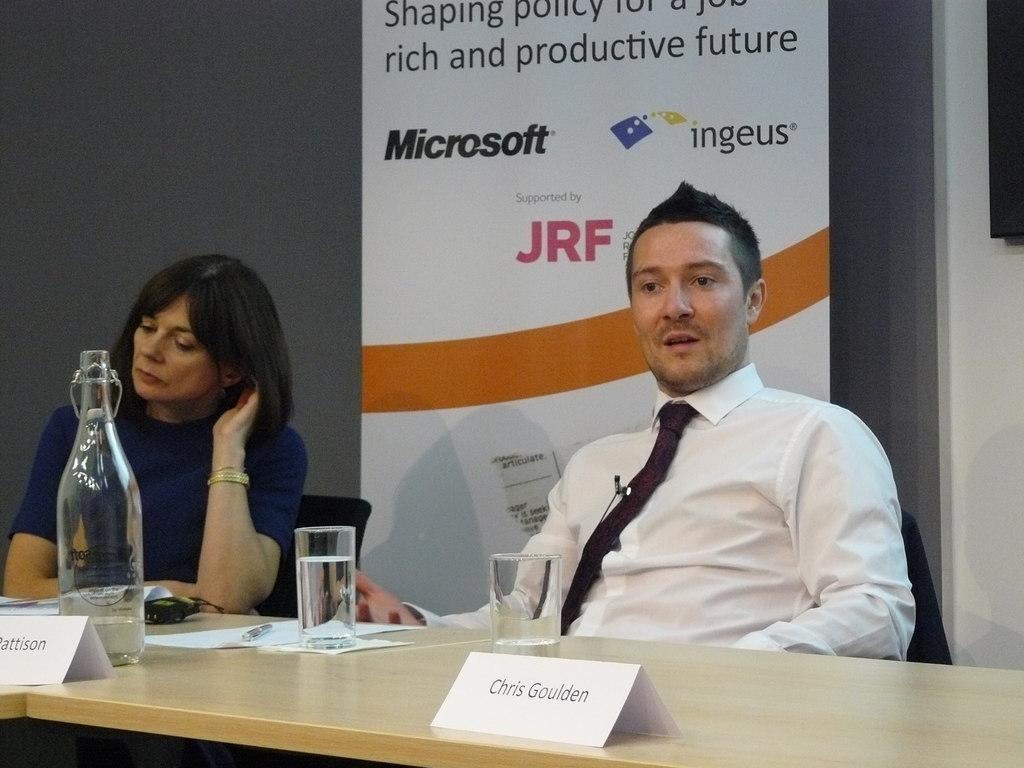In one or two sentences, can you explain what this image depicts? In this image there is a woman sitting with blue dress and there is a man with white shirt is talking. At the back there is a hoarding, there is a bottle, glass, paper and pen on the table. 